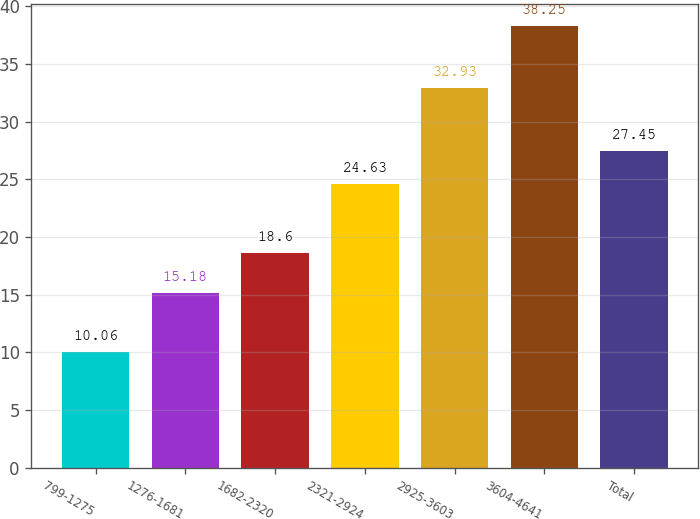<chart> <loc_0><loc_0><loc_500><loc_500><bar_chart><fcel>799-1275<fcel>1276-1681<fcel>1682-2320<fcel>2321-2924<fcel>2925-3603<fcel>3604-4641<fcel>Total<nl><fcel>10.06<fcel>15.18<fcel>18.6<fcel>24.63<fcel>32.93<fcel>38.25<fcel>27.45<nl></chart> 